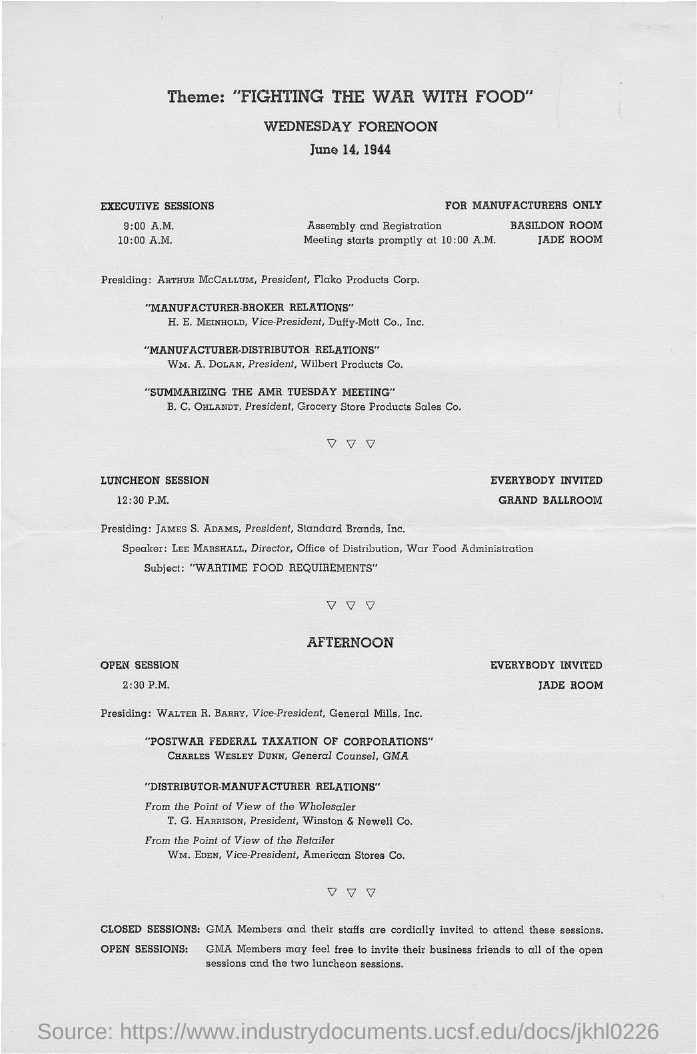Who is the vice-president of American Stores Co.?
Offer a terse response. WM. EDEN. Who is the vice-president of General Mills, Inc?
Ensure brevity in your answer.  Walter R. Barry. Who is the president of Standard Brands, Inc.?
Offer a terse response. James S. Adams. Who is the president of Wilbert Products Co.?
Provide a short and direct response. Wm. A. Dolan. 